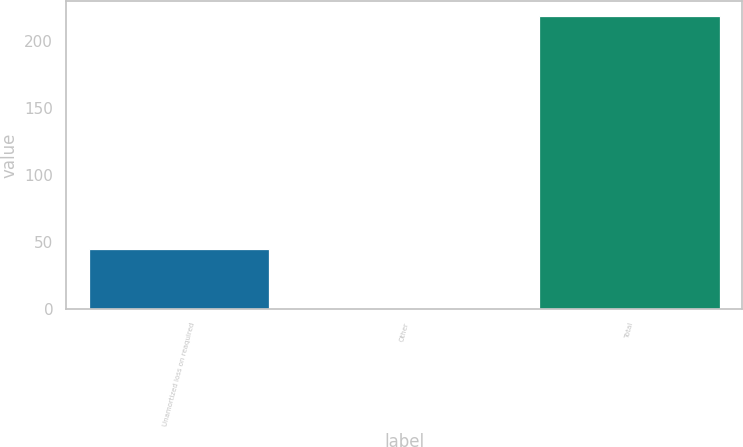Convert chart to OTSL. <chart><loc_0><loc_0><loc_500><loc_500><bar_chart><fcel>Unamortized loss on reaquired<fcel>Other<fcel>Total<nl><fcel>45<fcel>0.3<fcel>219.4<nl></chart> 